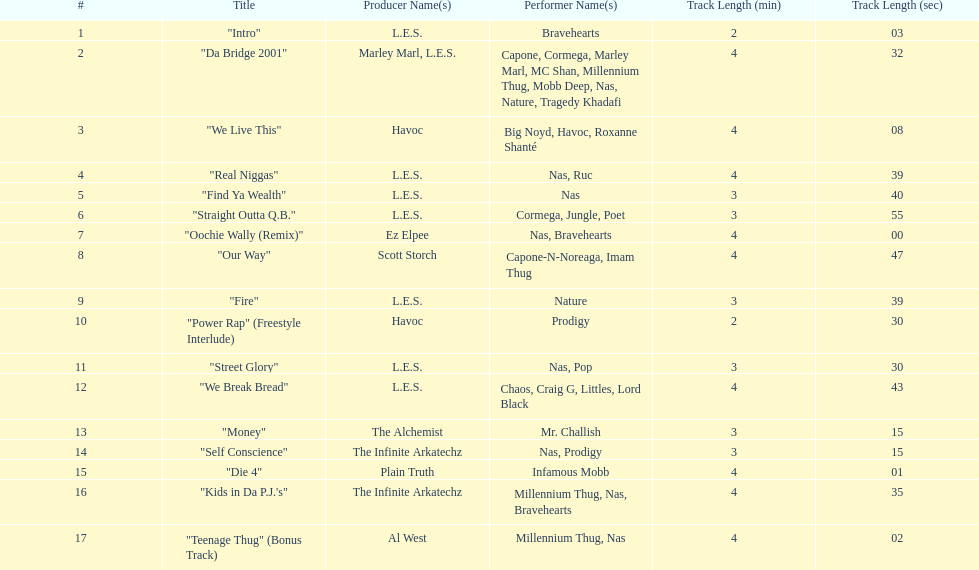What song was performed before "fire"? "Our Way". 